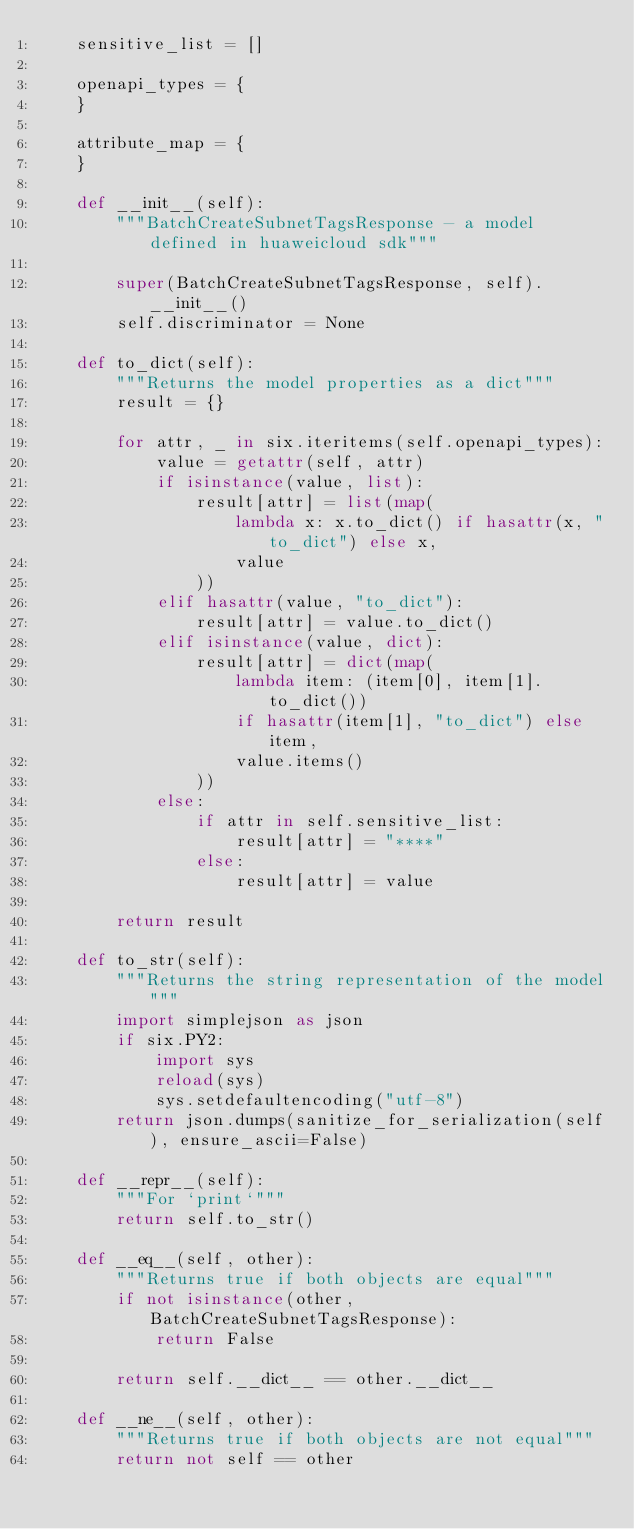Convert code to text. <code><loc_0><loc_0><loc_500><loc_500><_Python_>    sensitive_list = []

    openapi_types = {
    }

    attribute_map = {
    }

    def __init__(self):
        """BatchCreateSubnetTagsResponse - a model defined in huaweicloud sdk"""
        
        super(BatchCreateSubnetTagsResponse, self).__init__()
        self.discriminator = None

    def to_dict(self):
        """Returns the model properties as a dict"""
        result = {}

        for attr, _ in six.iteritems(self.openapi_types):
            value = getattr(self, attr)
            if isinstance(value, list):
                result[attr] = list(map(
                    lambda x: x.to_dict() if hasattr(x, "to_dict") else x,
                    value
                ))
            elif hasattr(value, "to_dict"):
                result[attr] = value.to_dict()
            elif isinstance(value, dict):
                result[attr] = dict(map(
                    lambda item: (item[0], item[1].to_dict())
                    if hasattr(item[1], "to_dict") else item,
                    value.items()
                ))
            else:
                if attr in self.sensitive_list:
                    result[attr] = "****"
                else:
                    result[attr] = value

        return result

    def to_str(self):
        """Returns the string representation of the model"""
        import simplejson as json
        if six.PY2:
            import sys
            reload(sys)
            sys.setdefaultencoding("utf-8")
        return json.dumps(sanitize_for_serialization(self), ensure_ascii=False)

    def __repr__(self):
        """For `print`"""
        return self.to_str()

    def __eq__(self, other):
        """Returns true if both objects are equal"""
        if not isinstance(other, BatchCreateSubnetTagsResponse):
            return False

        return self.__dict__ == other.__dict__

    def __ne__(self, other):
        """Returns true if both objects are not equal"""
        return not self == other
</code> 